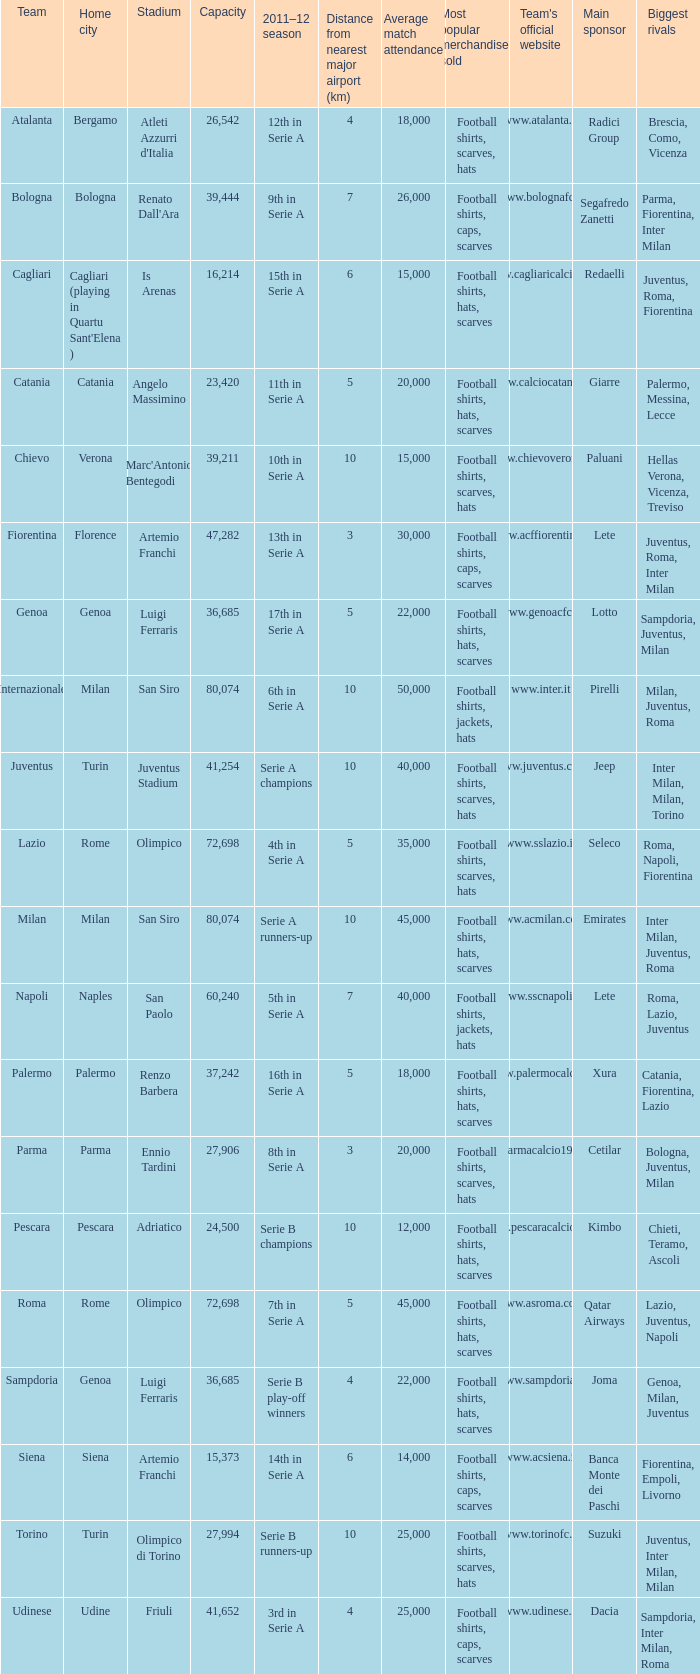What team had a capacity of over 26,542, a home city of milan, and finished the 2011-2012 season 6th in serie a? Internazionale. 